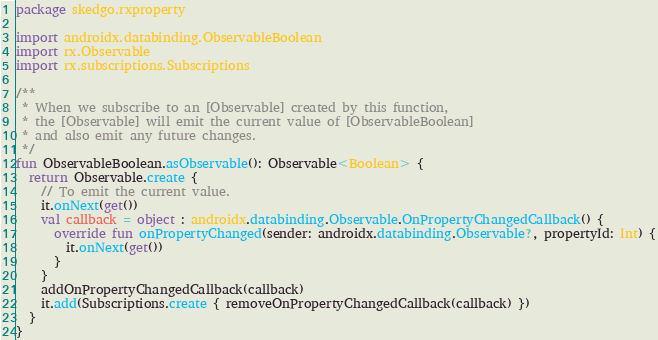<code> <loc_0><loc_0><loc_500><loc_500><_Kotlin_>package skedgo.rxproperty

import androidx.databinding.ObservableBoolean
import rx.Observable
import rx.subscriptions.Subscriptions

/**
 * When we subscribe to an [Observable] created by this function,
 * the [Observable] will emit the current value of [ObservableBoolean]
 * and also emit any future changes.
 */
fun ObservableBoolean.asObservable(): Observable<Boolean> {
  return Observable.create {
    // To emit the current value.
    it.onNext(get())
    val callback = object : androidx.databinding.Observable.OnPropertyChangedCallback() {
      override fun onPropertyChanged(sender: androidx.databinding.Observable?, propertyId: Int) {
        it.onNext(get())
      }
    }
    addOnPropertyChangedCallback(callback)
    it.add(Subscriptions.create { removeOnPropertyChangedCallback(callback) })
  }
}
</code> 